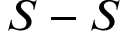Convert formula to latex. <formula><loc_0><loc_0><loc_500><loc_500>S - S</formula> 